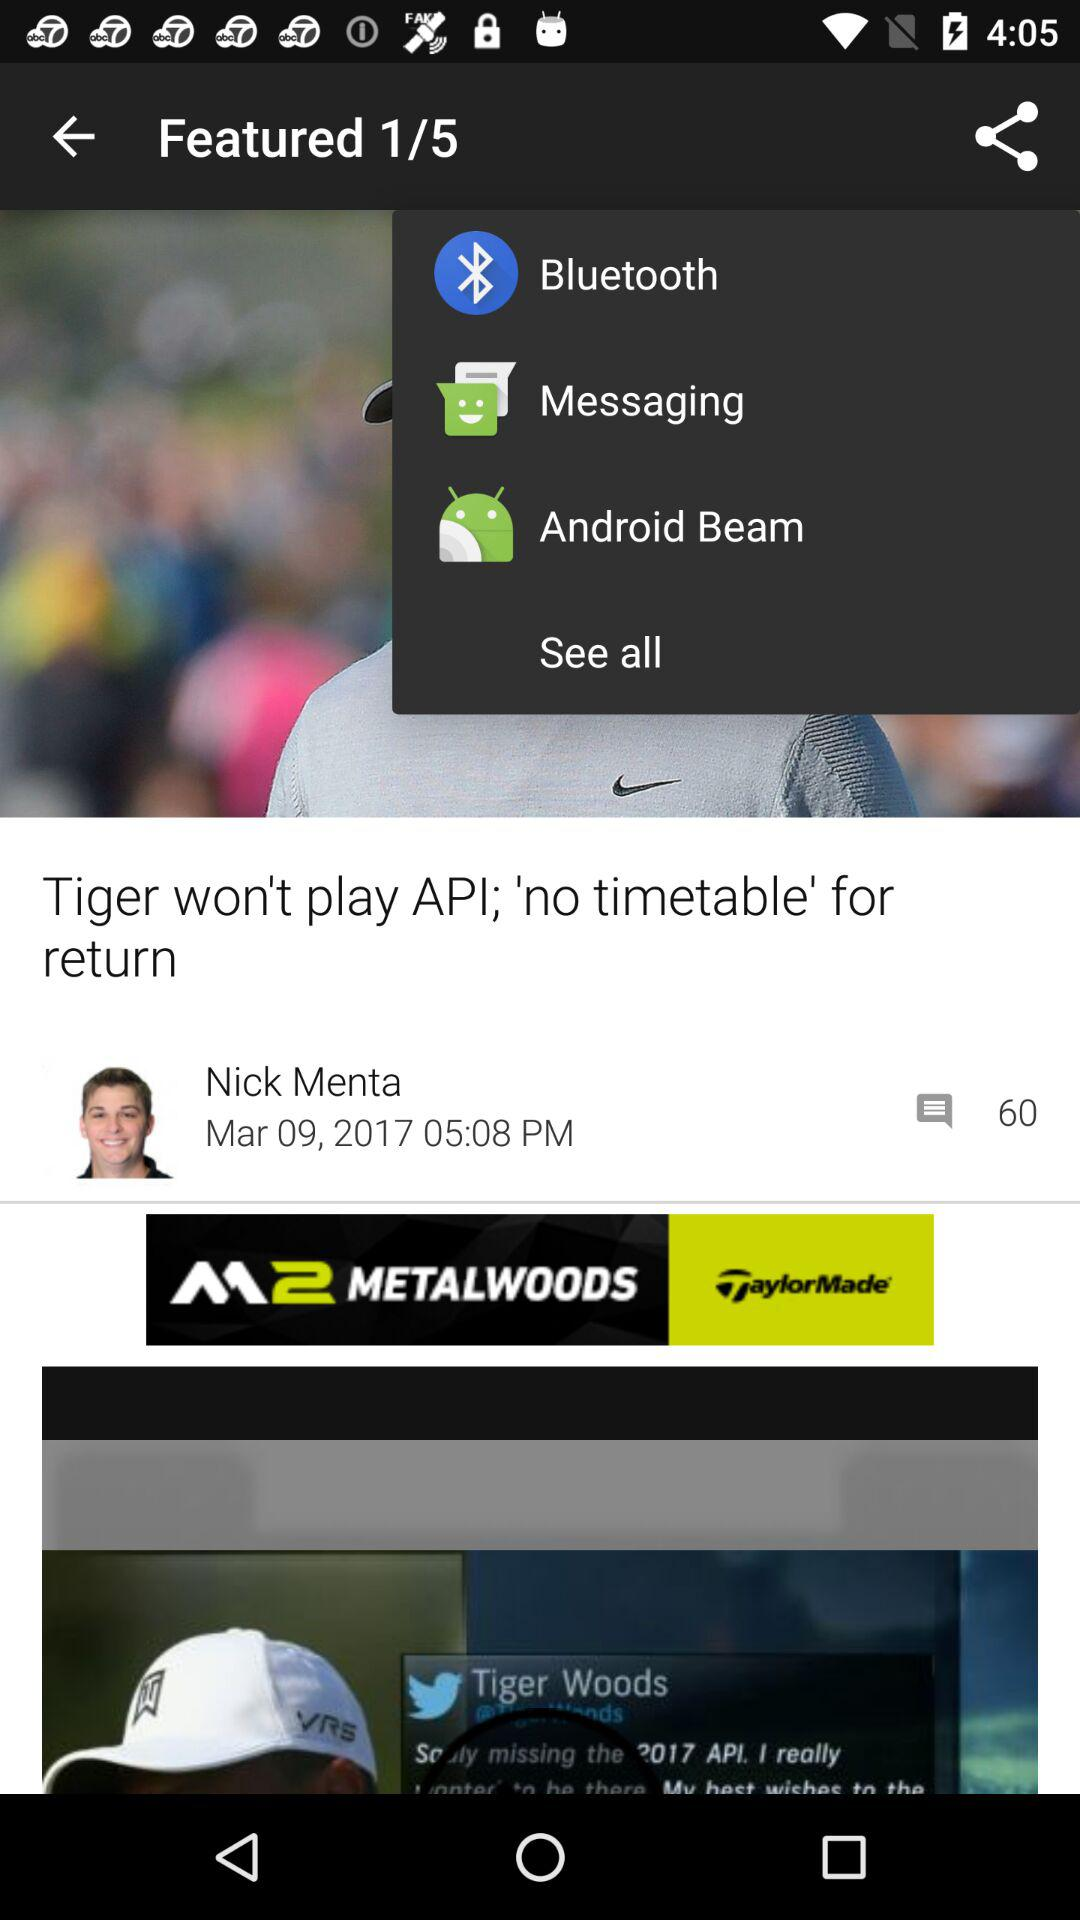How many comments in total are there? There are 60 comments. 